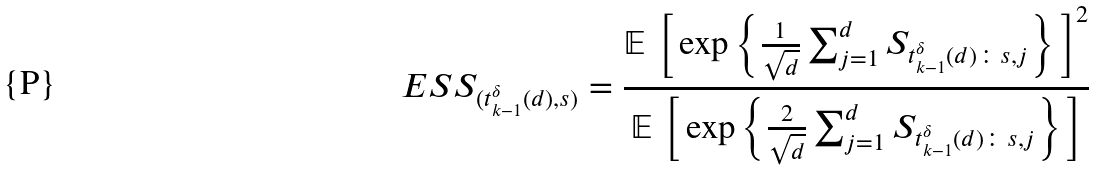Convert formula to latex. <formula><loc_0><loc_0><loc_500><loc_500>E S S _ { ( t _ { k - 1 } ^ { \delta } ( d ) , s ) } = \frac { \mathbb { E } \, \left [ \, \exp \left \{ \frac { 1 } { \sqrt { d } } \sum _ { j = 1 } ^ { d } S _ { t _ { k - 1 } ^ { \delta } ( d ) \colon s , j } \right \} \, \right ] ^ { 2 } } { \mathbb { E } \, \left [ \, \exp \left \{ \frac { 2 } { \sqrt { d } } \sum _ { j = 1 } ^ { d } S _ { t _ { k - 1 } ^ { \delta } ( d ) \colon s , j } \right \} \, \right ] } \</formula> 